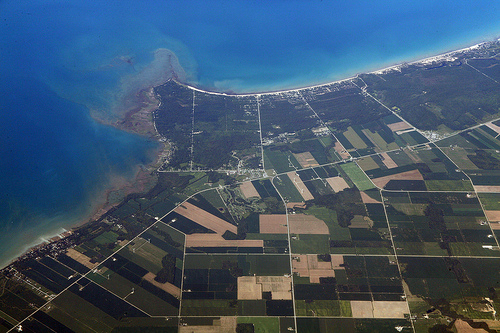<image>
Is the sea above the earth? No. The sea is not positioned above the earth. The vertical arrangement shows a different relationship. 